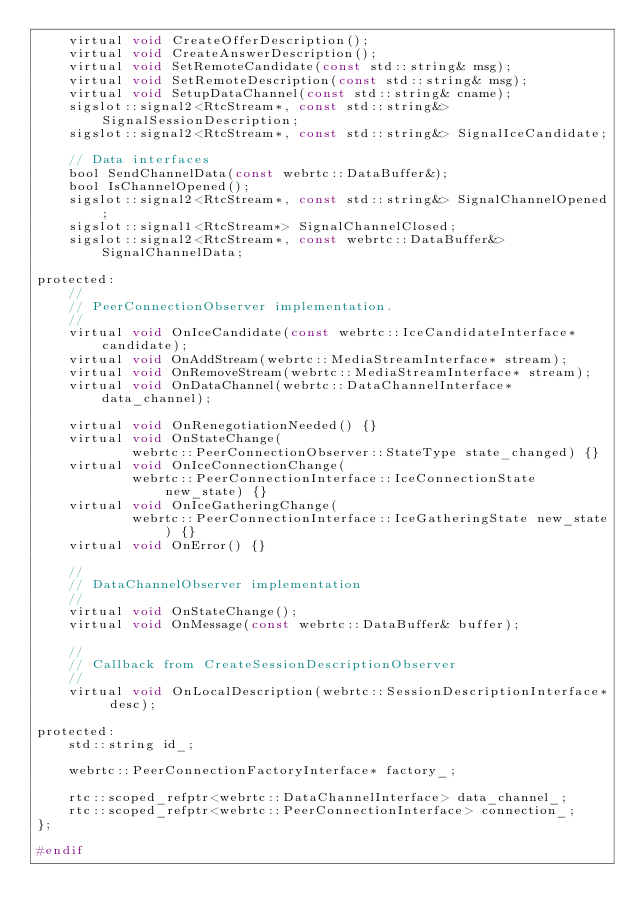<code> <loc_0><loc_0><loc_500><loc_500><_C_>    virtual void CreateOfferDescription();
    virtual void CreateAnswerDescription();
    virtual void SetRemoteCandidate(const std::string& msg);
    virtual void SetRemoteDescription(const std::string& msg);
    virtual void SetupDataChannel(const std::string& cname);
    sigslot::signal2<RtcStream*, const std::string&> SignalSessionDescription;
    sigslot::signal2<RtcStream*, const std::string&> SignalIceCandidate;

    // Data interfaces
    bool SendChannelData(const webrtc::DataBuffer&);
    bool IsChannelOpened();
    sigslot::signal2<RtcStream*, const std::string&> SignalChannelOpened;
    sigslot::signal1<RtcStream*> SignalChannelClosed;
    sigslot::signal2<RtcStream*, const webrtc::DataBuffer&> SignalChannelData;

protected:
    //
    // PeerConnectionObserver implementation.
    //
    virtual void OnIceCandidate(const webrtc::IceCandidateInterface* candidate);
    virtual void OnAddStream(webrtc::MediaStreamInterface* stream);
    virtual void OnRemoveStream(webrtc::MediaStreamInterface* stream);
    virtual void OnDataChannel(webrtc::DataChannelInterface* data_channel);

    virtual void OnRenegotiationNeeded() {}
    virtual void OnStateChange(
            webrtc::PeerConnectionObserver::StateType state_changed) {}
    virtual void OnIceConnectionChange(
            webrtc::PeerConnectionInterface::IceConnectionState new_state) {}
    virtual void OnIceGatheringChange(
            webrtc::PeerConnectionInterface::IceGatheringState new_state) {}
    virtual void OnError() {}

    //
    // DataChannelObserver implementation
    //
    virtual void OnStateChange();
    virtual void OnMessage(const webrtc::DataBuffer& buffer);

    //
    // Callback from CreateSessionDescriptionObserver
    //
    virtual void OnLocalDescription(webrtc::SessionDescriptionInterface* desc);

protected:
    std::string id_;

    webrtc::PeerConnectionFactoryInterface* factory_;

    rtc::scoped_refptr<webrtc::DataChannelInterface> data_channel_;
    rtc::scoped_refptr<webrtc::PeerConnectionInterface> connection_;
};

#endif
</code> 